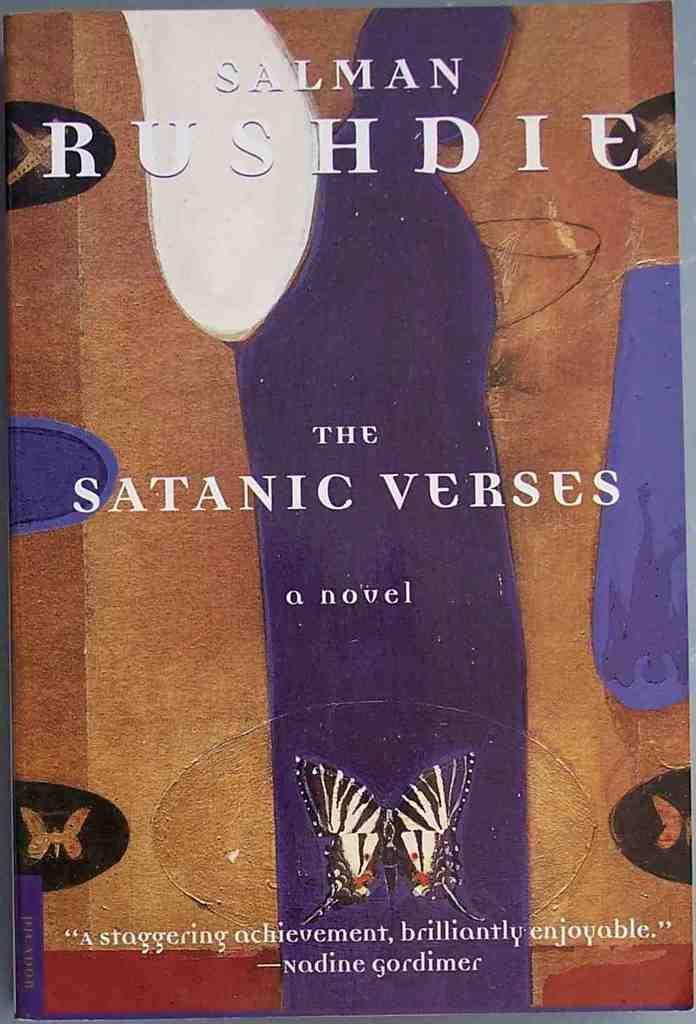What object can be seen in the image? There is a book in the image. What is the color of the book? The book is brown in color. What type of text is on the book? The book has white text on it. What genre might the book belong to? The book appears to be a novel. What image is present at the bottom of the book? There is an image of a butterfly at the bottom of the book. What type of doctor is featured on the cover of the book? There is no doctor featured on the cover of the book, as the image provided does not mention a cover. 